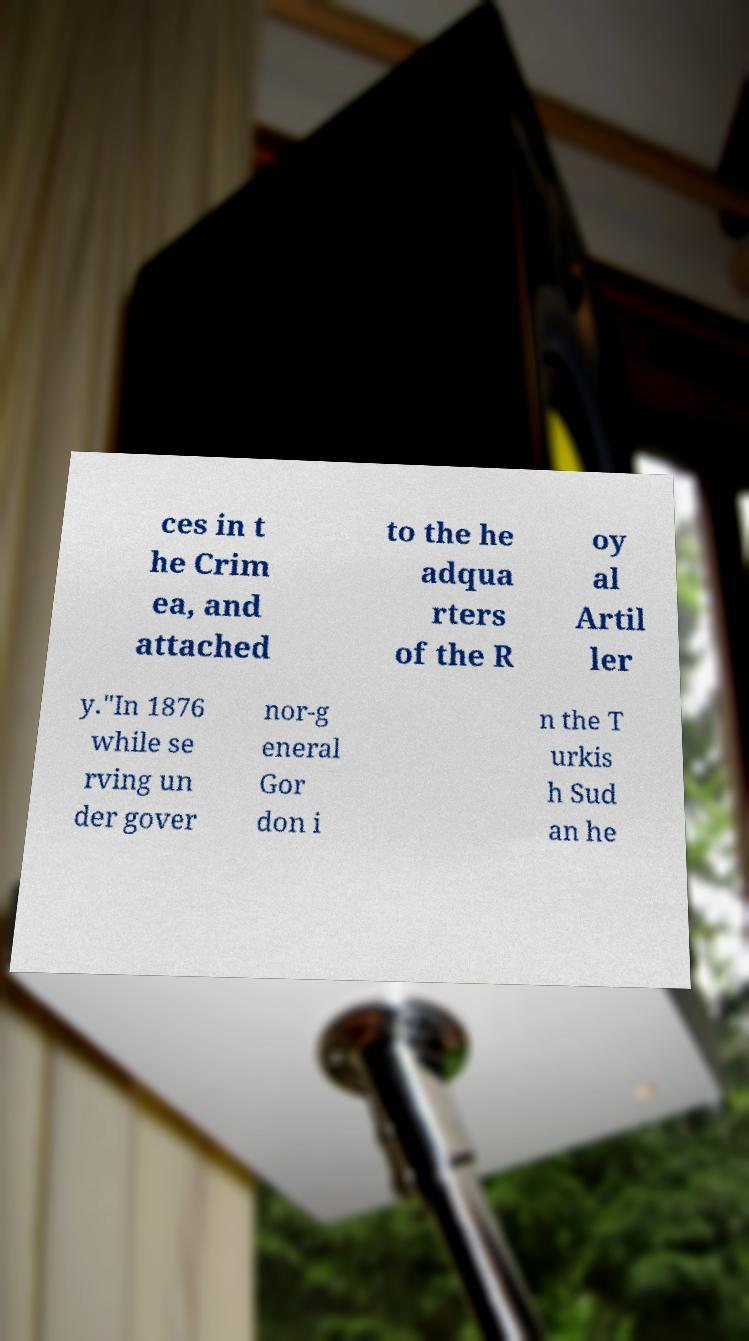Can you accurately transcribe the text from the provided image for me? ces in t he Crim ea, and attached to the he adqua rters of the R oy al Artil ler y."In 1876 while se rving un der gover nor-g eneral Gor don i n the T urkis h Sud an he 